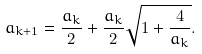Convert formula to latex. <formula><loc_0><loc_0><loc_500><loc_500>a _ { k + 1 } = \frac { a _ { k } } { 2 } + \frac { a _ { k } } { 2 } \sqrt { 1 + \frac { 4 } { a _ { k } } } .</formula> 